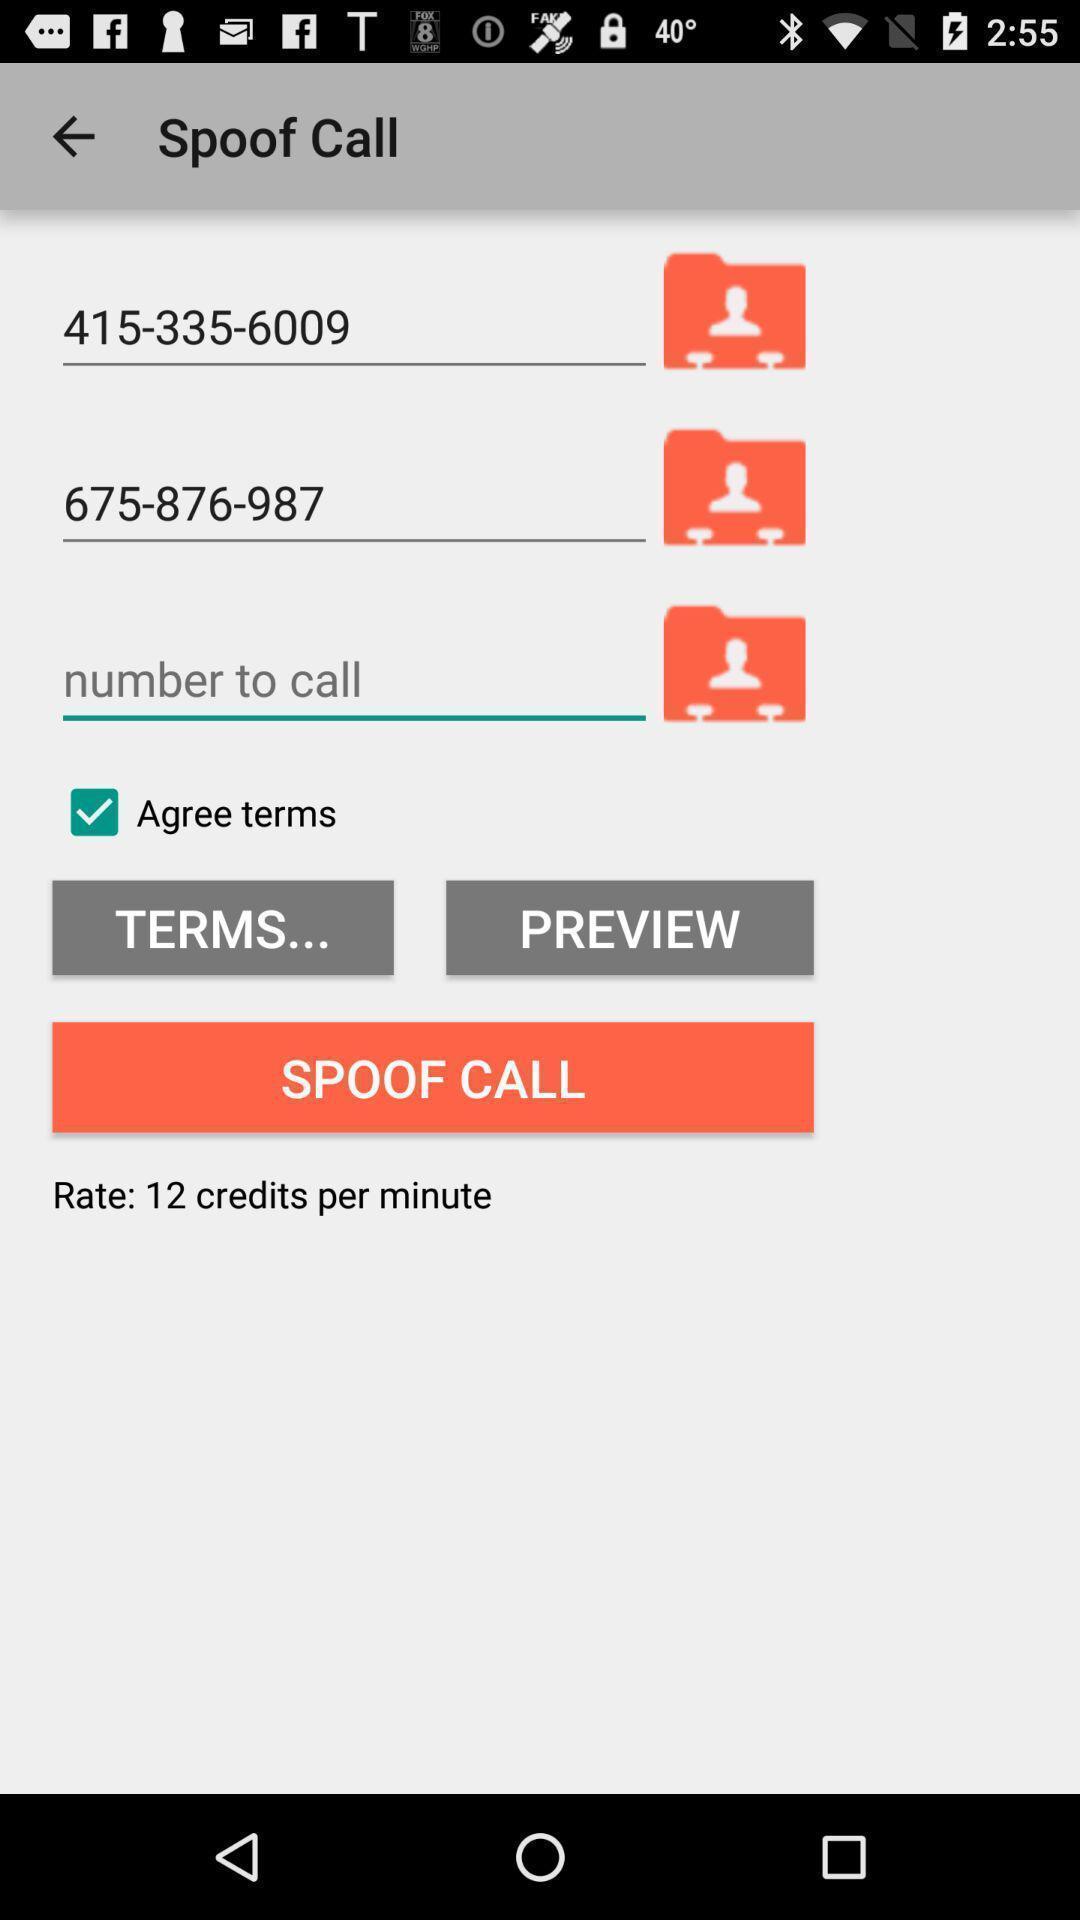What can you discern from this picture? Screen shows contact details. 